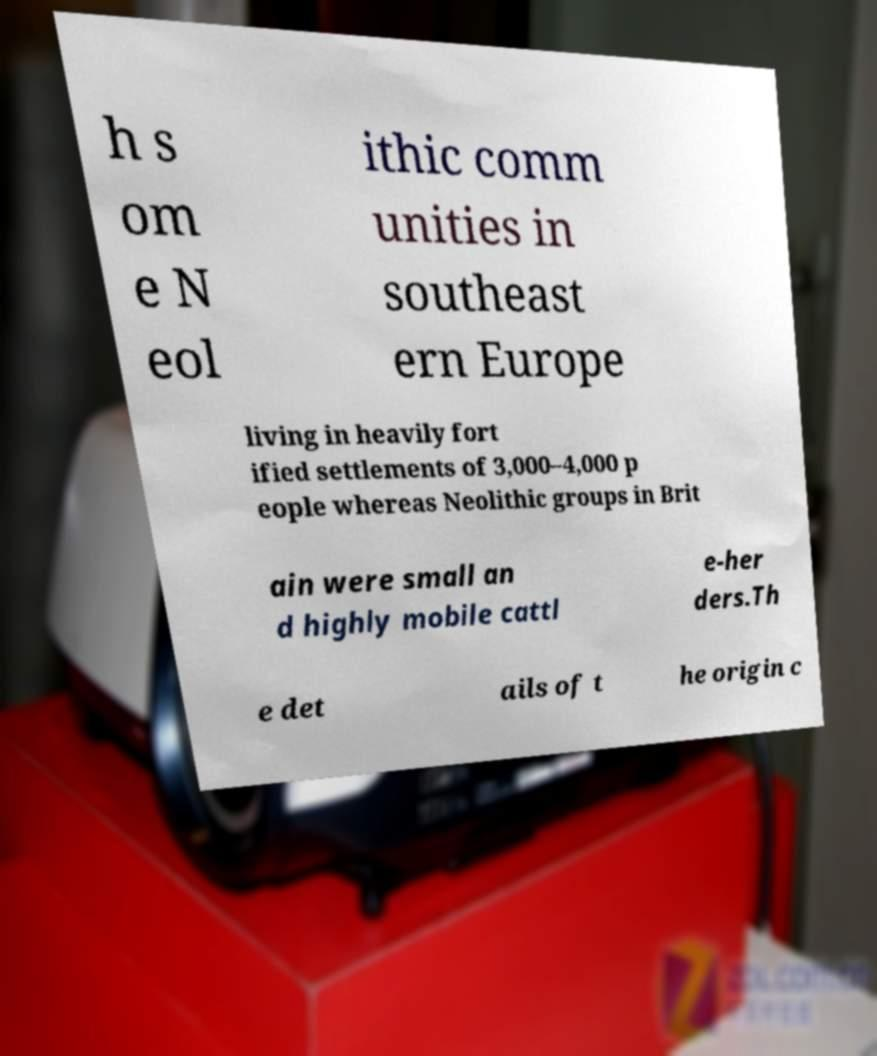Can you read and provide the text displayed in the image?This photo seems to have some interesting text. Can you extract and type it out for me? h s om e N eol ithic comm unities in southeast ern Europe living in heavily fort ified settlements of 3,000–4,000 p eople whereas Neolithic groups in Brit ain were small an d highly mobile cattl e-her ders.Th e det ails of t he origin c 